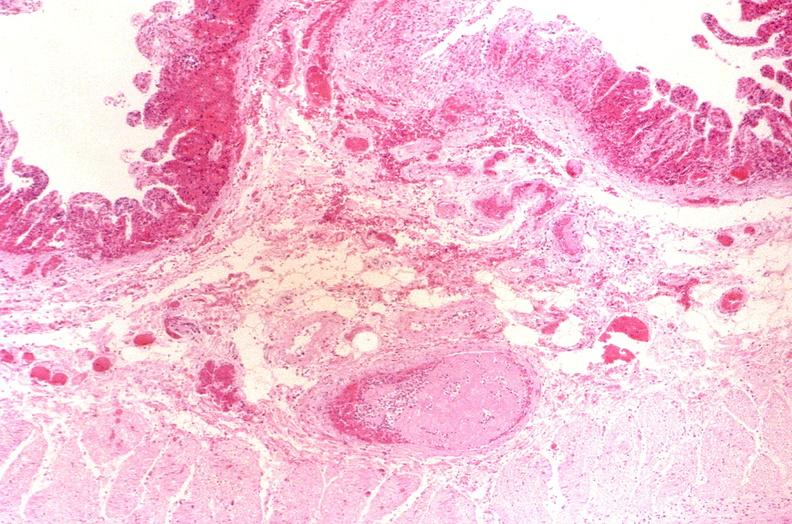s rheumatoid arthritis present?
Answer the question using a single word or phrase. No 